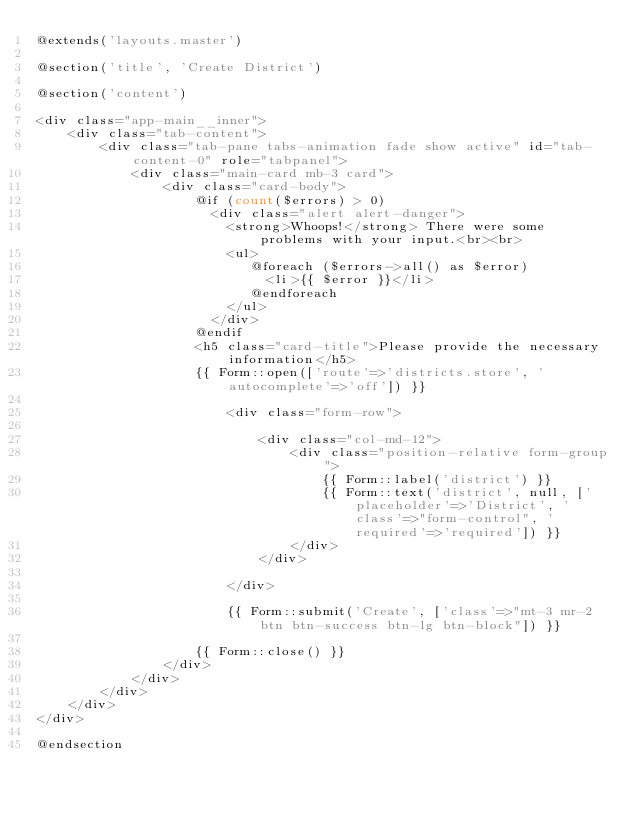Convert code to text. <code><loc_0><loc_0><loc_500><loc_500><_PHP_>@extends('layouts.master') 

@section('title', 'Create District') 

@section('content')

<div class="app-main__inner">
    <div class="tab-content">
        <div class="tab-pane tabs-animation fade show active" id="tab-content-0" role="tabpanel">
            <div class="main-card mb-3 card">
                <div class="card-body">
                    @if (count($errors) > 0)
                      <div class="alert alert-danger">
                        <strong>Whoops!</strong> There were some problems with your input.<br><br>
                        <ul>
                           @foreach ($errors->all() as $error)
                             <li>{{ $error }}</li>
                           @endforeach
                        </ul>
                      </div>
                    @endif
                    <h5 class="card-title">Please provide the necessary information</h5>
                    {{ Form::open(['route'=>'districts.store', 'autocomplete'=>'off']) }}

                        <div class="form-row">

                            <div class="col-md-12">
                                <div class="position-relative form-group">
                                    {{ Form::label('district') }}
                                    {{ Form::text('district', null, ['placeholder'=>'District', 'class'=>"form-control", 'required'=>'required']) }}
                                </div>
                            </div>

                        </div>

                        {{ Form::submit('Create', ['class'=>"mt-3 mr-2 btn btn-success btn-lg btn-block"]) }}

                    {{ Form::close() }}
                </div>
            </div>
        </div>
    </div>
</div>

@endsection</code> 